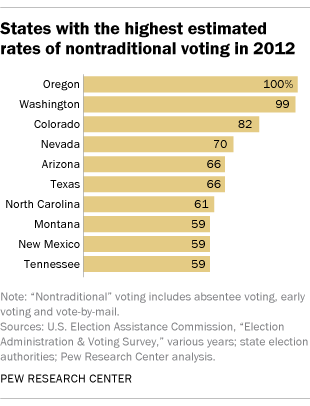Draw attention to some important aspects in this diagram. The state with the second highest estimated rates of nontraditional votes is Washington. The average of the last three bars is 59. 